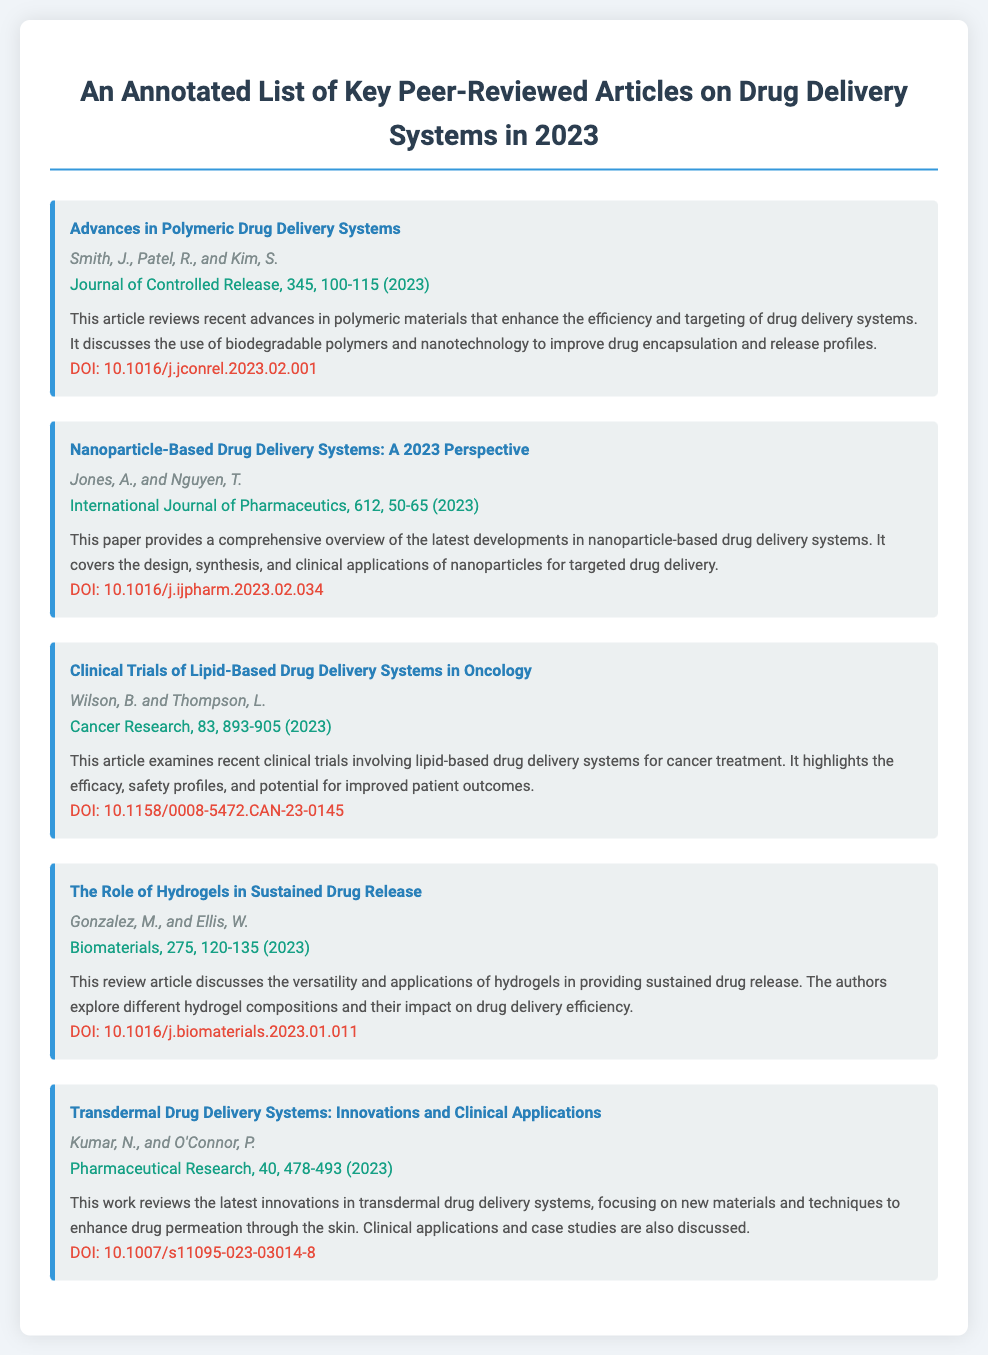What is the title of the first article? The title of the first article is listed at the beginning of the first bibliography item.
Answer: Advances in Polymeric Drug Delivery Systems Who are the authors of the article on clinical trials? The authors of the clinical trials article are specified in the respective bibliography entry.
Answer: Wilson, B. and Thompson, L What journal published the article on nanoparticle-based drug delivery systems? The journal name is provided in the bibliography entry for the nanoparticle article.
Answer: International Journal of Pharmaceutics How many pages does the article on lipid-based drug delivery systems cover? The page range is noted in the bibliography entry for the article on lipid-based drug delivery systems.
Answer: 893-905 Which article discusses hydrogels? The relevant article title that includes hydrogels is specified.
Answer: The Role of Hydrogels in Sustained Drug Release What is the DOI of the article authored by Kumar and O'Connor? The DOI is found in the bibliography entry for the article by Kumar and O'Connor.
Answer: 10.1007/s11095-023-03014-8 How many articles are listed in total? The total number of bibliography items in the document provides the count of articles.
Answer: Five What is the primary focus of the article by Smith, Patel, and Kim? The primary focus is explained in the annotation provided in their bibliography entry.
Answer: Advances in polymeric materials for drug delivery systems 